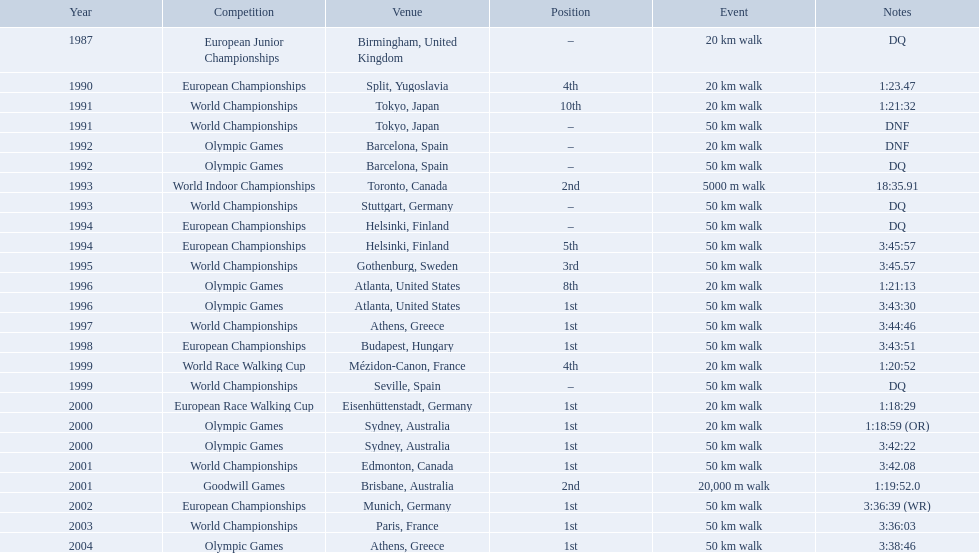In 1990, where did robert korzeniowski rank? 4th. What was robert korzeniowski's standing in the 1993 world indoor championships? 2nd. How much time was required for the 50km walk in the 2004 olympics? 3:38:46. 